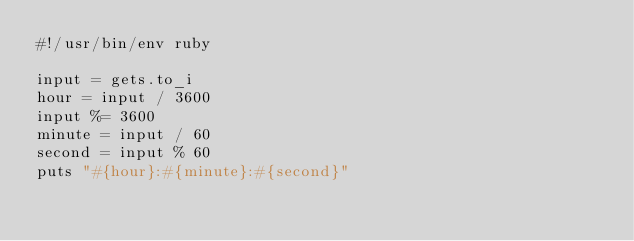<code> <loc_0><loc_0><loc_500><loc_500><_Ruby_>#!/usr/bin/env ruby

input = gets.to_i
hour = input / 3600
input %= 3600
minute = input / 60
second = input % 60
puts "#{hour}:#{minute}:#{second}"
</code> 